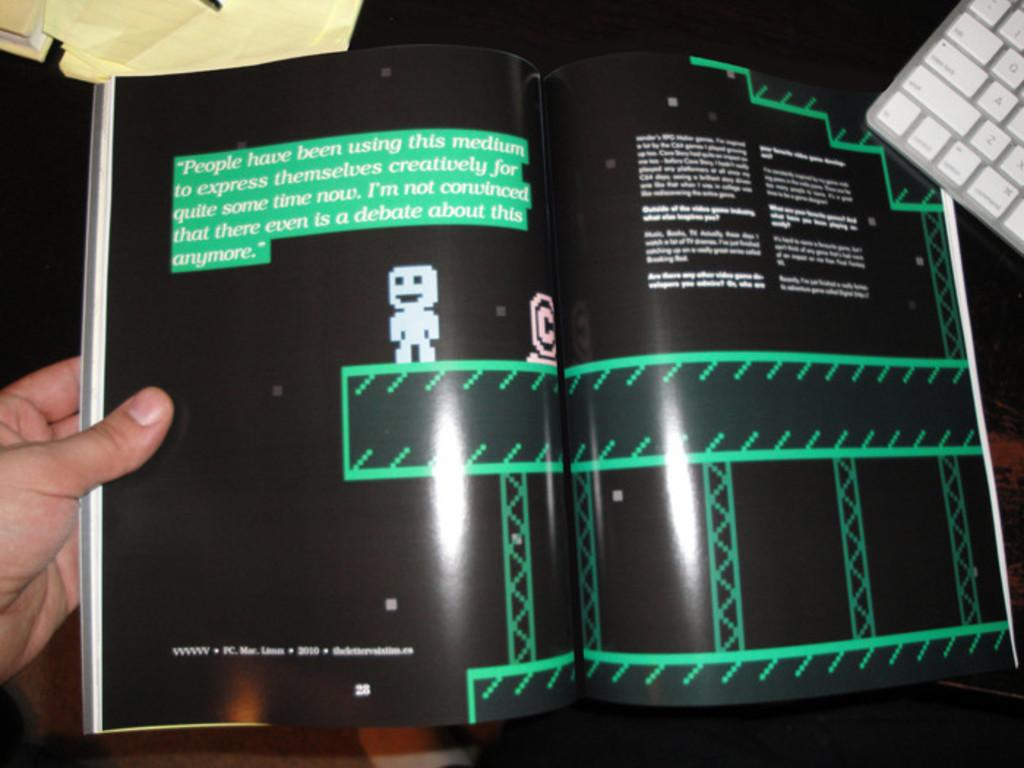What is the person in the image holding? The person is holding a book in the image. What can be seen on the book or nearby? There is text visible in the image, which may be on the book or on other items nearby. What type of images are present in the image? There are cartoon images in the image. What can be seen in the background of the image? There is a keyboard and papers in the background of the image. What type of soup is being served in the image? There is no soup present in the image; it features a person holding a book with cartoon images and text, along with a keyboard and papers in the background. Is there a woman in the image? The provided facts do not mention the gender of the person holding the book, so we cannot definitively say if it is a woman or not. 